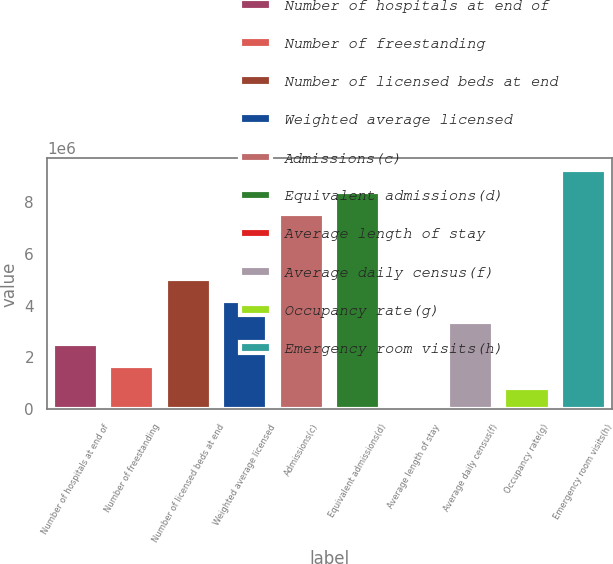Convert chart. <chart><loc_0><loc_0><loc_500><loc_500><bar_chart><fcel>Number of hospitals at end of<fcel>Number of freestanding<fcel>Number of licensed beds at end<fcel>Weighted average licensed<fcel>Admissions(c)<fcel>Equivalent admissions(d)<fcel>Average length of stay<fcel>Average daily census(f)<fcel>Occupancy rate(g)<fcel>Emergency room visits(h)<nl><fcel>2.51349e+06<fcel>1.67566e+06<fcel>5.02698e+06<fcel>4.18915e+06<fcel>7.54047e+06<fcel>8.3783e+06<fcel>4.9<fcel>3.35132e+06<fcel>837834<fcel>9.21613e+06<nl></chart> 